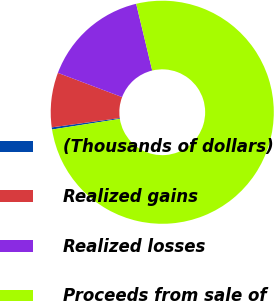Convert chart to OTSL. <chart><loc_0><loc_0><loc_500><loc_500><pie_chart><fcel>(Thousands of dollars)<fcel>Realized gains<fcel>Realized losses<fcel>Proceeds from sale of<nl><fcel>0.31%<fcel>7.91%<fcel>15.5%<fcel>76.27%<nl></chart> 